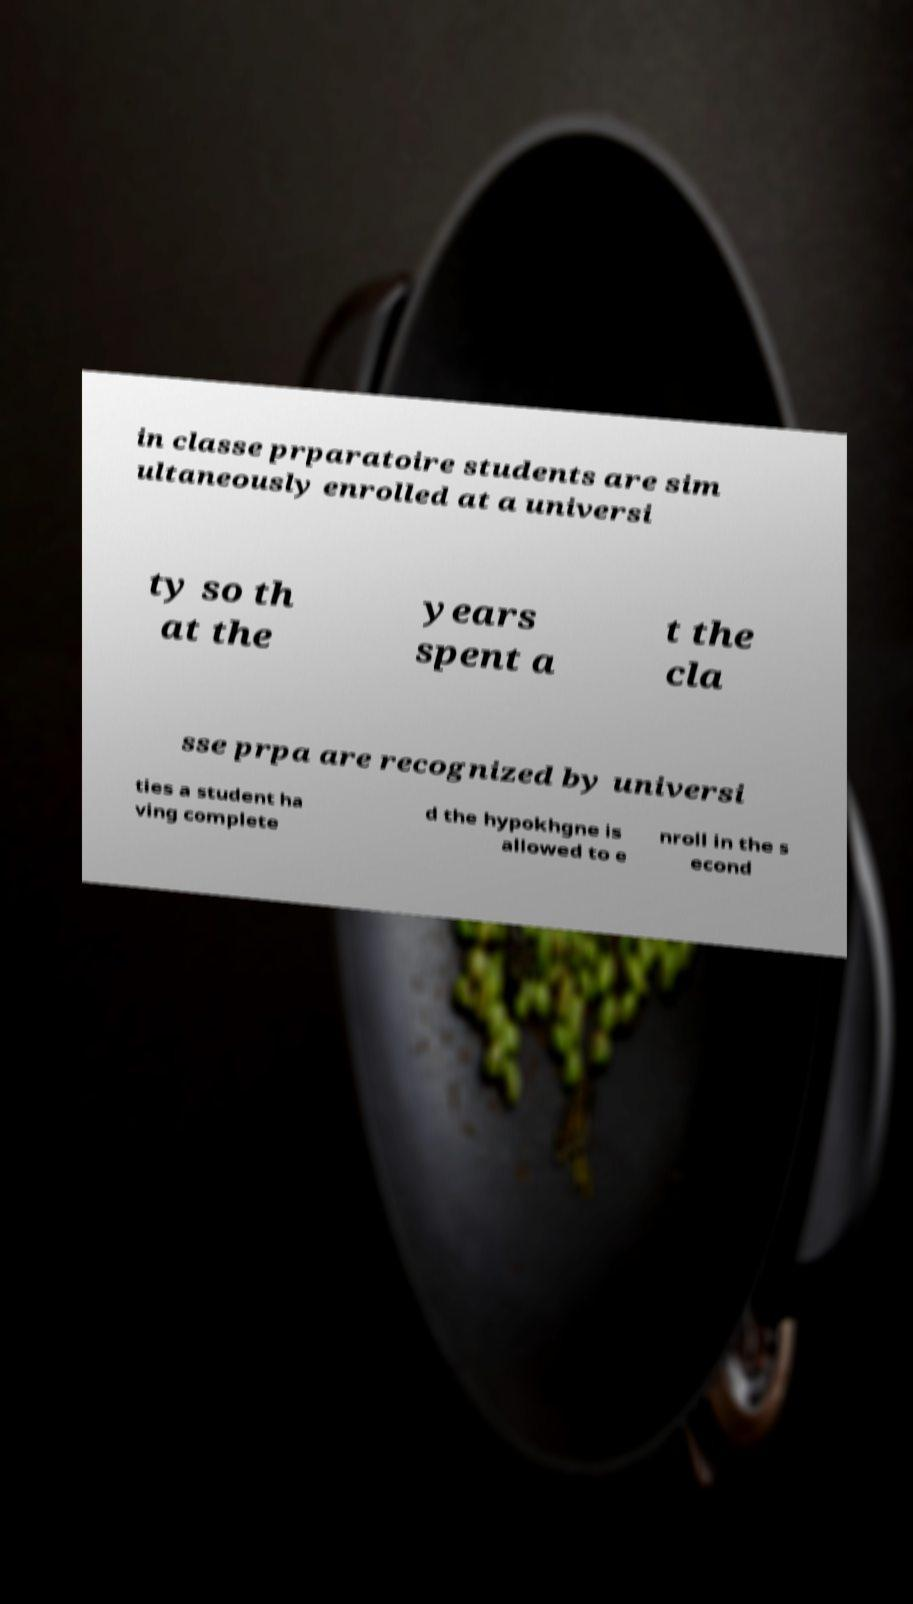I need the written content from this picture converted into text. Can you do that? in classe prparatoire students are sim ultaneously enrolled at a universi ty so th at the years spent a t the cla sse prpa are recognized by universi ties a student ha ving complete d the hypokhgne is allowed to e nroll in the s econd 